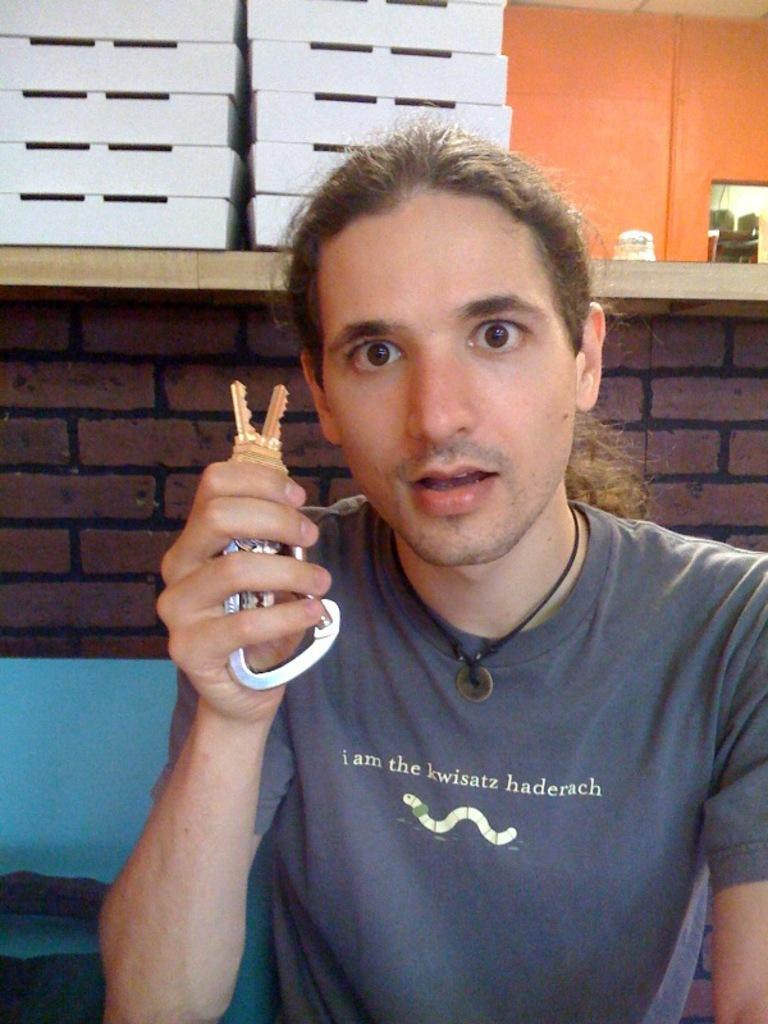Who or what is the main subject in the image? There is a person in the image. What is the person holding in the image? The person is holding a key. What can be seen in the background of the image? There is a wall and a bench in the background of the image. What is placed on top of the bench? There are white color baskets on the top of the bench. What is the person writing on the bench in the image? There is no indication that the person is writing anything in the image. 